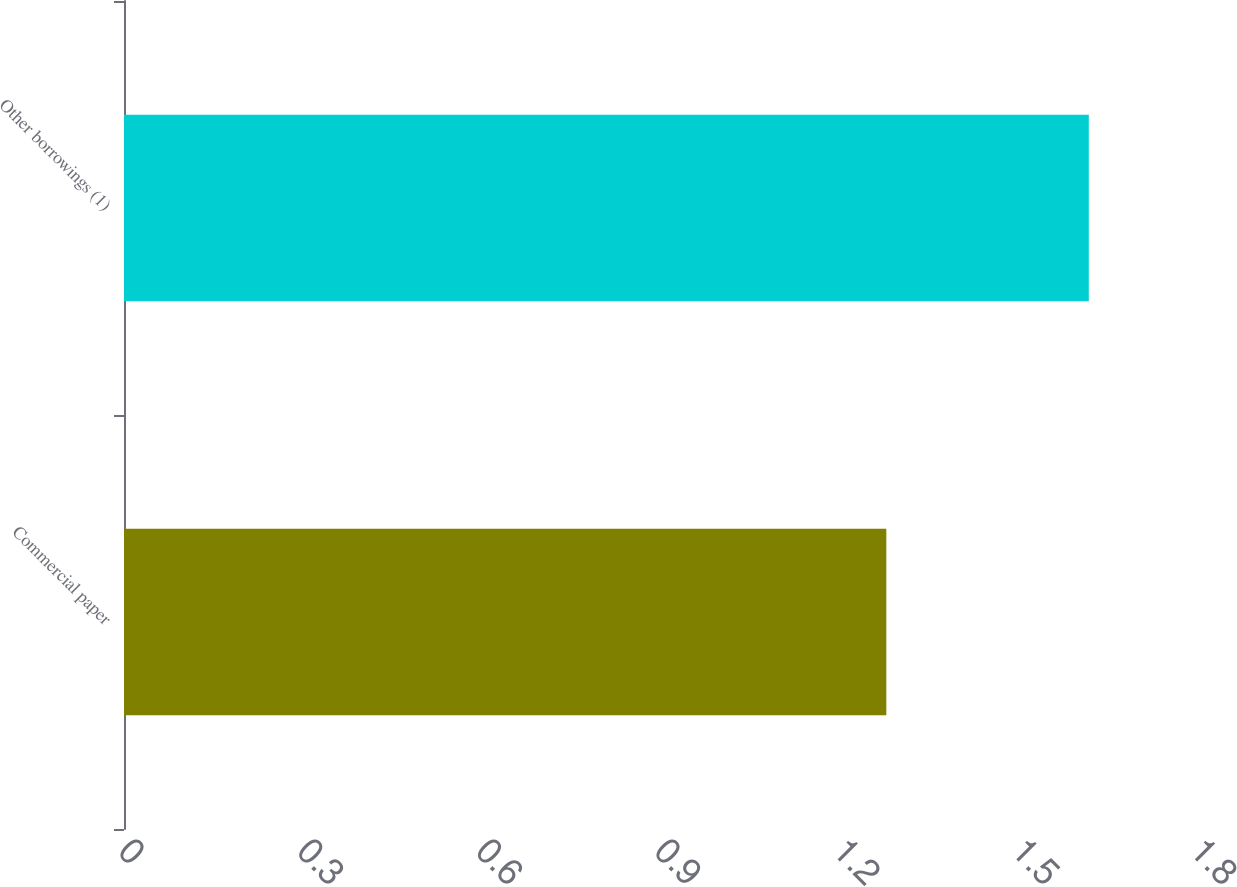Convert chart to OTSL. <chart><loc_0><loc_0><loc_500><loc_500><bar_chart><fcel>Commercial paper<fcel>Other borrowings (1)<nl><fcel>1.28<fcel>1.62<nl></chart> 